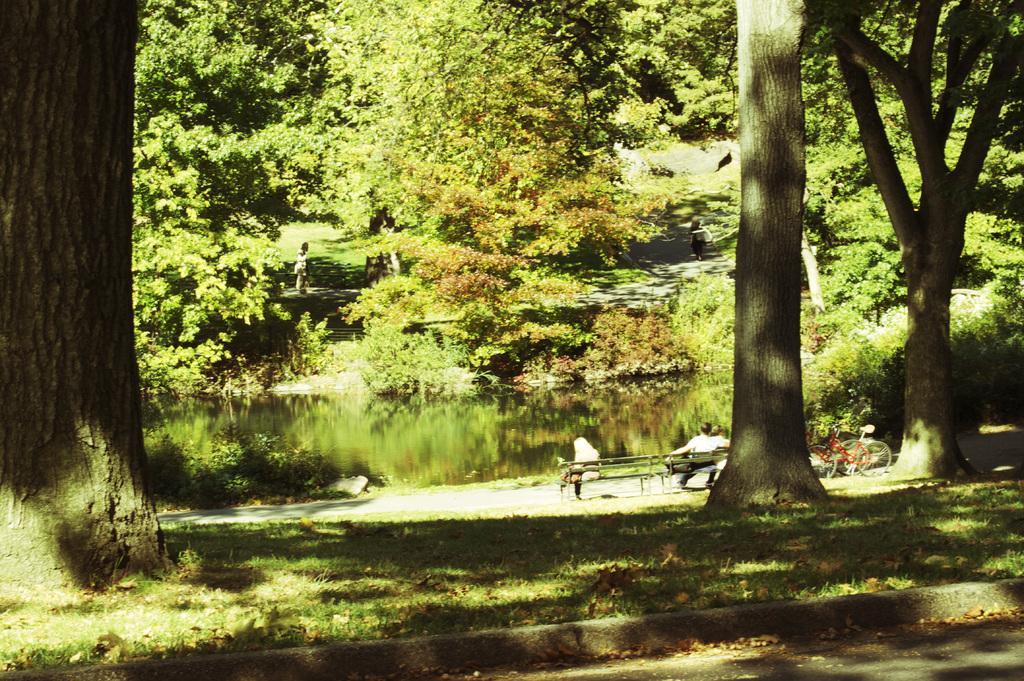In one or two sentences, can you explain what this image depicts? In this image in the front there's grass on the ground. In the background there are trees, there is water, there are bicycles and there are persons sitting on the bench. 